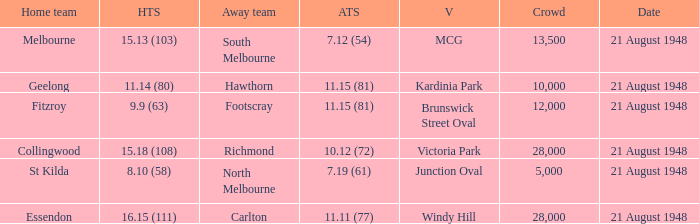15 (81), what is the location of the game? Brunswick Street Oval. 